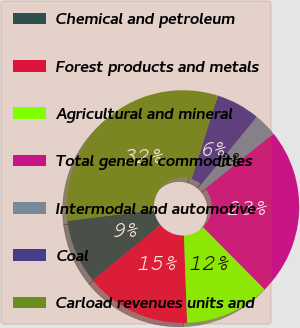<chart> <loc_0><loc_0><loc_500><loc_500><pie_chart><fcel>Chemical and petroleum<fcel>Forest products and metals<fcel>Agricultural and mineral<fcel>Total general commodities<fcel>Intermodal and automotive<fcel>Coal<fcel>Carload revenues units and<nl><fcel>8.96%<fcel>14.67%<fcel>11.82%<fcel>23.38%<fcel>3.25%<fcel>6.1%<fcel>31.81%<nl></chart> 